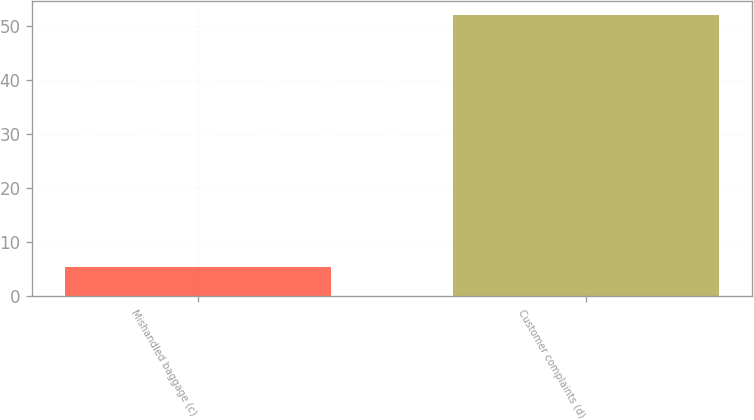<chart> <loc_0><loc_0><loc_500><loc_500><bar_chart><fcel>Mishandled baggage (c)<fcel>Customer complaints (d)<nl><fcel>5.3<fcel>51.9<nl></chart> 